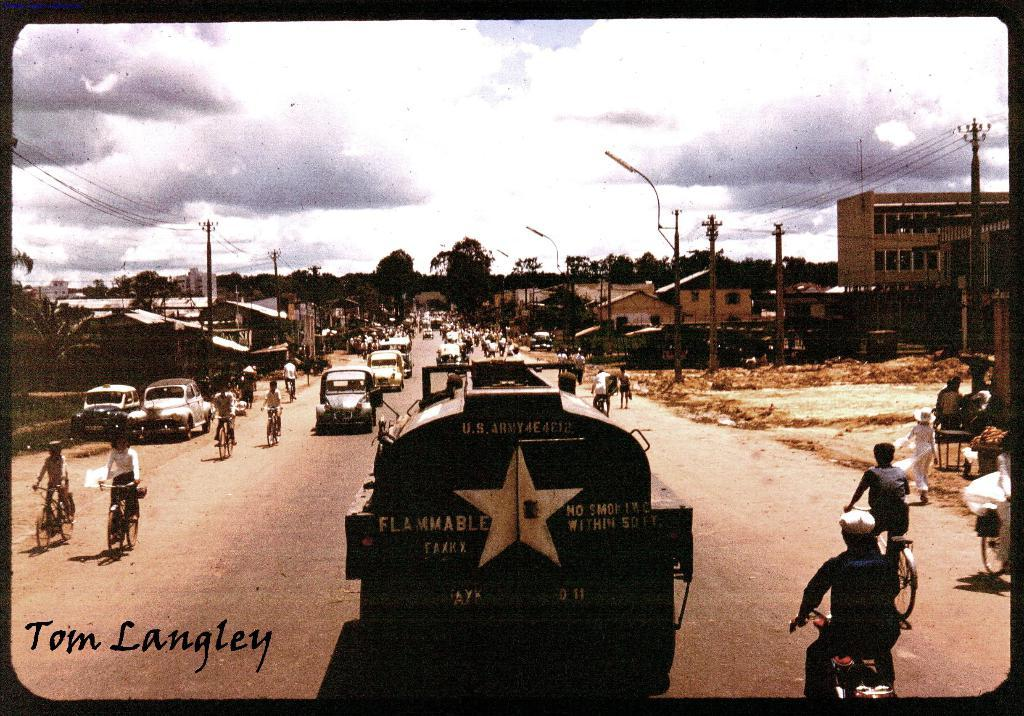<image>
Relay a brief, clear account of the picture shown. An old city with lots of bikes and a gas truck that says Flammable. 